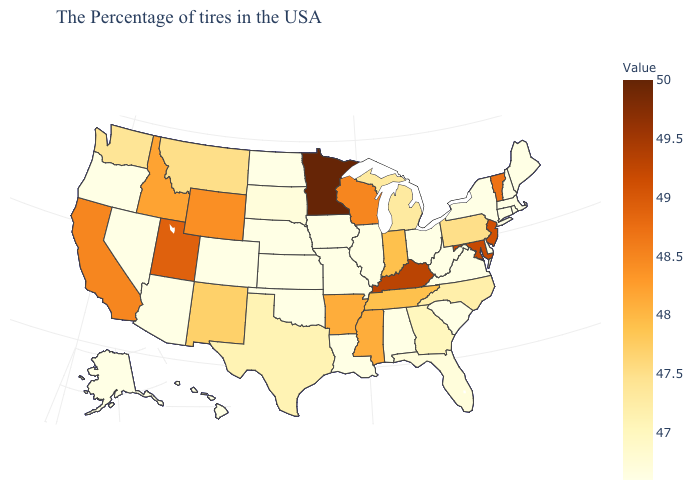Which states have the lowest value in the South?
Quick response, please. Delaware, Virginia, South Carolina, West Virginia, Alabama, Louisiana, Oklahoma. Does Kentucky have the highest value in the South?
Quick response, please. Yes. Does Arkansas have the lowest value in the South?
Answer briefly. No. Does Nevada have the highest value in the USA?
Short answer required. No. Among the states that border Mississippi , does Arkansas have the highest value?
Write a very short answer. Yes. 